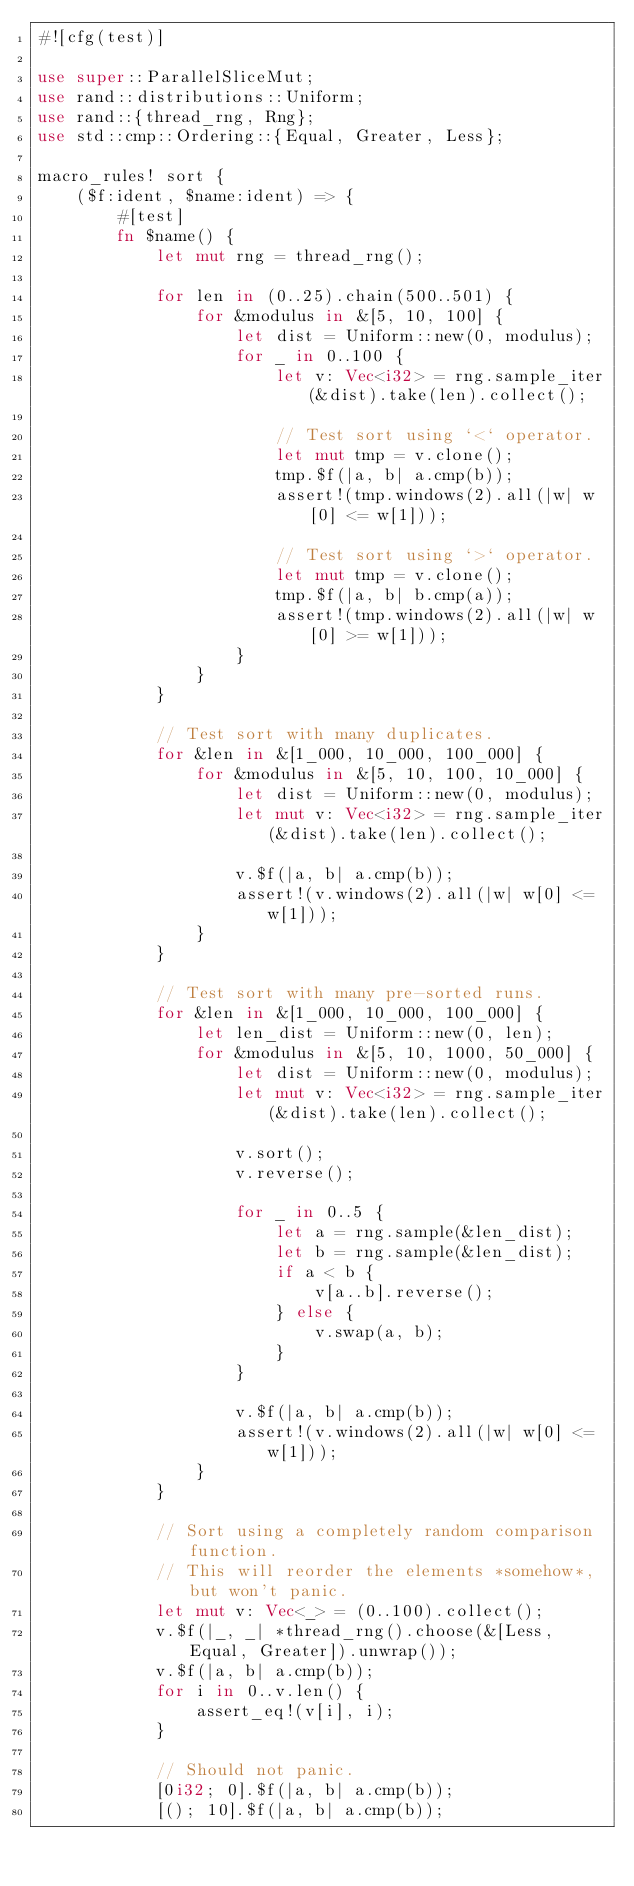Convert code to text. <code><loc_0><loc_0><loc_500><loc_500><_Rust_>#![cfg(test)]

use super::ParallelSliceMut;
use rand::distributions::Uniform;
use rand::{thread_rng, Rng};
use std::cmp::Ordering::{Equal, Greater, Less};

macro_rules! sort {
    ($f:ident, $name:ident) => {
        #[test]
        fn $name() {
            let mut rng = thread_rng();

            for len in (0..25).chain(500..501) {
                for &modulus in &[5, 10, 100] {
                    let dist = Uniform::new(0, modulus);
                    for _ in 0..100 {
                        let v: Vec<i32> = rng.sample_iter(&dist).take(len).collect();

                        // Test sort using `<` operator.
                        let mut tmp = v.clone();
                        tmp.$f(|a, b| a.cmp(b));
                        assert!(tmp.windows(2).all(|w| w[0] <= w[1]));

                        // Test sort using `>` operator.
                        let mut tmp = v.clone();
                        tmp.$f(|a, b| b.cmp(a));
                        assert!(tmp.windows(2).all(|w| w[0] >= w[1]));
                    }
                }
            }

            // Test sort with many duplicates.
            for &len in &[1_000, 10_000, 100_000] {
                for &modulus in &[5, 10, 100, 10_000] {
                    let dist = Uniform::new(0, modulus);
                    let mut v: Vec<i32> = rng.sample_iter(&dist).take(len).collect();

                    v.$f(|a, b| a.cmp(b));
                    assert!(v.windows(2).all(|w| w[0] <= w[1]));
                }
            }

            // Test sort with many pre-sorted runs.
            for &len in &[1_000, 10_000, 100_000] {
                let len_dist = Uniform::new(0, len);
                for &modulus in &[5, 10, 1000, 50_000] {
                    let dist = Uniform::new(0, modulus);
                    let mut v: Vec<i32> = rng.sample_iter(&dist).take(len).collect();

                    v.sort();
                    v.reverse();

                    for _ in 0..5 {
                        let a = rng.sample(&len_dist);
                        let b = rng.sample(&len_dist);
                        if a < b {
                            v[a..b].reverse();
                        } else {
                            v.swap(a, b);
                        }
                    }

                    v.$f(|a, b| a.cmp(b));
                    assert!(v.windows(2).all(|w| w[0] <= w[1]));
                }
            }

            // Sort using a completely random comparison function.
            // This will reorder the elements *somehow*, but won't panic.
            let mut v: Vec<_> = (0..100).collect();
            v.$f(|_, _| *thread_rng().choose(&[Less, Equal, Greater]).unwrap());
            v.$f(|a, b| a.cmp(b));
            for i in 0..v.len() {
                assert_eq!(v[i], i);
            }

            // Should not panic.
            [0i32; 0].$f(|a, b| a.cmp(b));
            [(); 10].$f(|a, b| a.cmp(b));</code> 